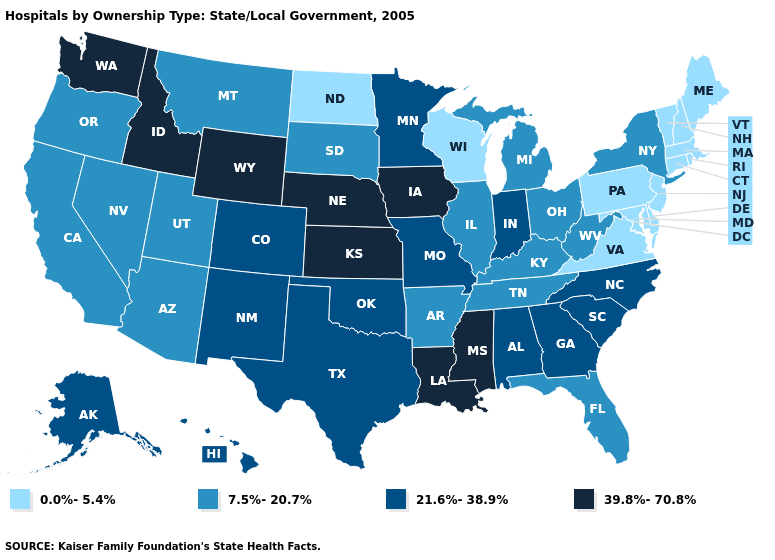What is the value of Wyoming?
Answer briefly. 39.8%-70.8%. Does Massachusetts have a lower value than Vermont?
Answer briefly. No. Which states have the lowest value in the Northeast?
Give a very brief answer. Connecticut, Maine, Massachusetts, New Hampshire, New Jersey, Pennsylvania, Rhode Island, Vermont. Among the states that border Kansas , does Missouri have the highest value?
Give a very brief answer. No. Does New Hampshire have the same value as Virginia?
Concise answer only. Yes. What is the lowest value in the USA?
Be succinct. 0.0%-5.4%. Does South Carolina have the lowest value in the South?
Write a very short answer. No. What is the lowest value in states that border Virginia?
Quick response, please. 0.0%-5.4%. Which states have the lowest value in the USA?
Short answer required. Connecticut, Delaware, Maine, Maryland, Massachusetts, New Hampshire, New Jersey, North Dakota, Pennsylvania, Rhode Island, Vermont, Virginia, Wisconsin. Name the states that have a value in the range 21.6%-38.9%?
Short answer required. Alabama, Alaska, Colorado, Georgia, Hawaii, Indiana, Minnesota, Missouri, New Mexico, North Carolina, Oklahoma, South Carolina, Texas. Name the states that have a value in the range 39.8%-70.8%?
Quick response, please. Idaho, Iowa, Kansas, Louisiana, Mississippi, Nebraska, Washington, Wyoming. What is the value of Georgia?
Concise answer only. 21.6%-38.9%. Does the first symbol in the legend represent the smallest category?
Write a very short answer. Yes. Does the map have missing data?
Quick response, please. No. Does Missouri have the lowest value in the MidWest?
Answer briefly. No. 